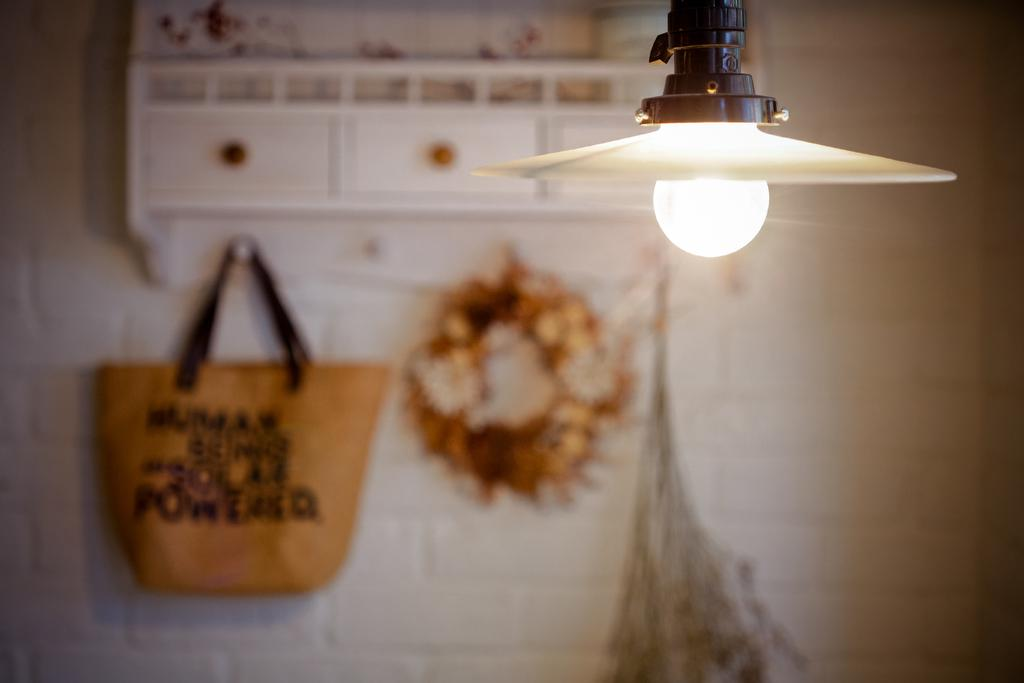What is the setting of the image? The image is of the inside of a room. What can be seen hanging on the wall on the left side of the image? There is a bag hanging on the wall on the left side of the image. What type of furniture is present in the image? There is a cabinet in the image. What is located on the right side of the image? There is a lamp on the right side of the image. What can be seen in the background of the image? There is a wall visible in the background of the image. How does the guide help people in the image? There is no guide present in the image, so it is not possible to answer that question. 